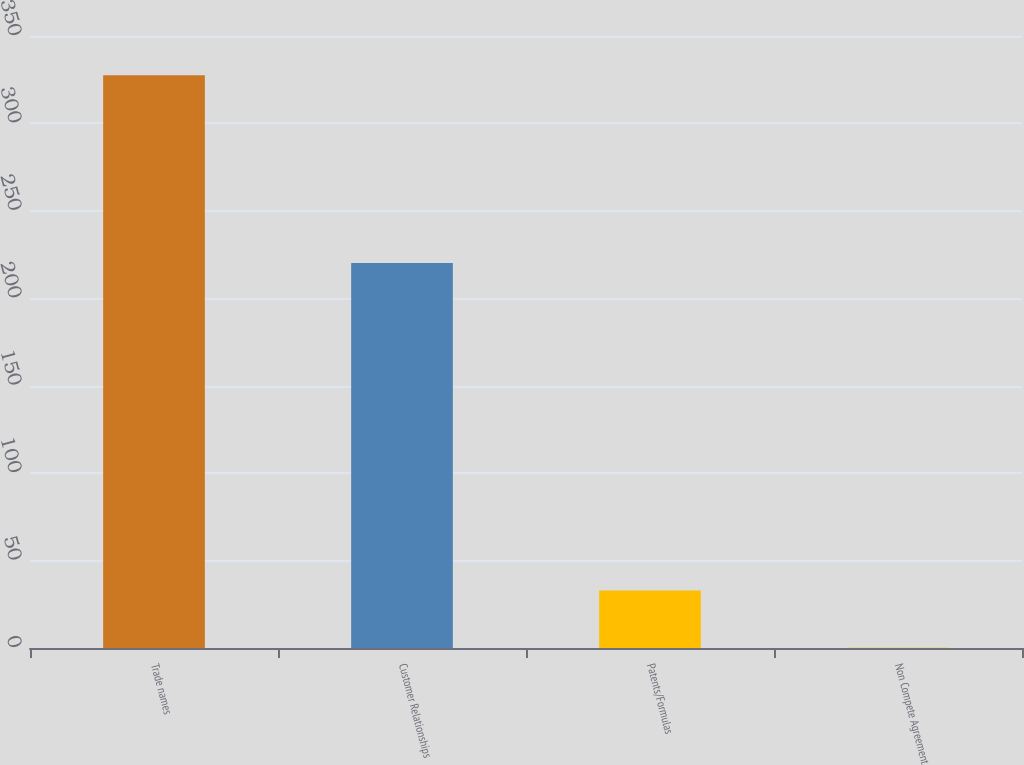Convert chart. <chart><loc_0><loc_0><loc_500><loc_500><bar_chart><fcel>Trade names<fcel>Customer Relationships<fcel>Patents/Formulas<fcel>Non Compete Agreement<nl><fcel>327.6<fcel>220.2<fcel>32.94<fcel>0.2<nl></chart> 